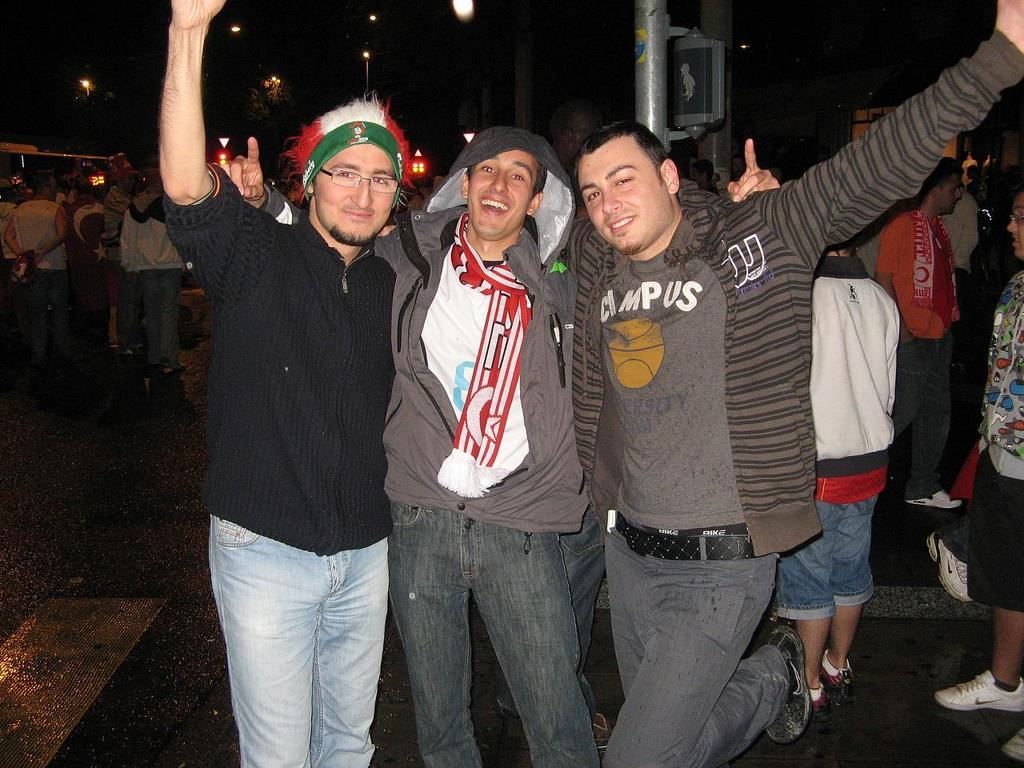What is happening in the center of the image? There are persons on the road in the center of the image. What can be seen in the background of the image? There is a pole, persons, a building, lights, and a tree in the background of the image. What type of pest can be seen crawling on the persons in the image? There is no pest visible in the image; it only shows persons on the road and various elements in the background. 